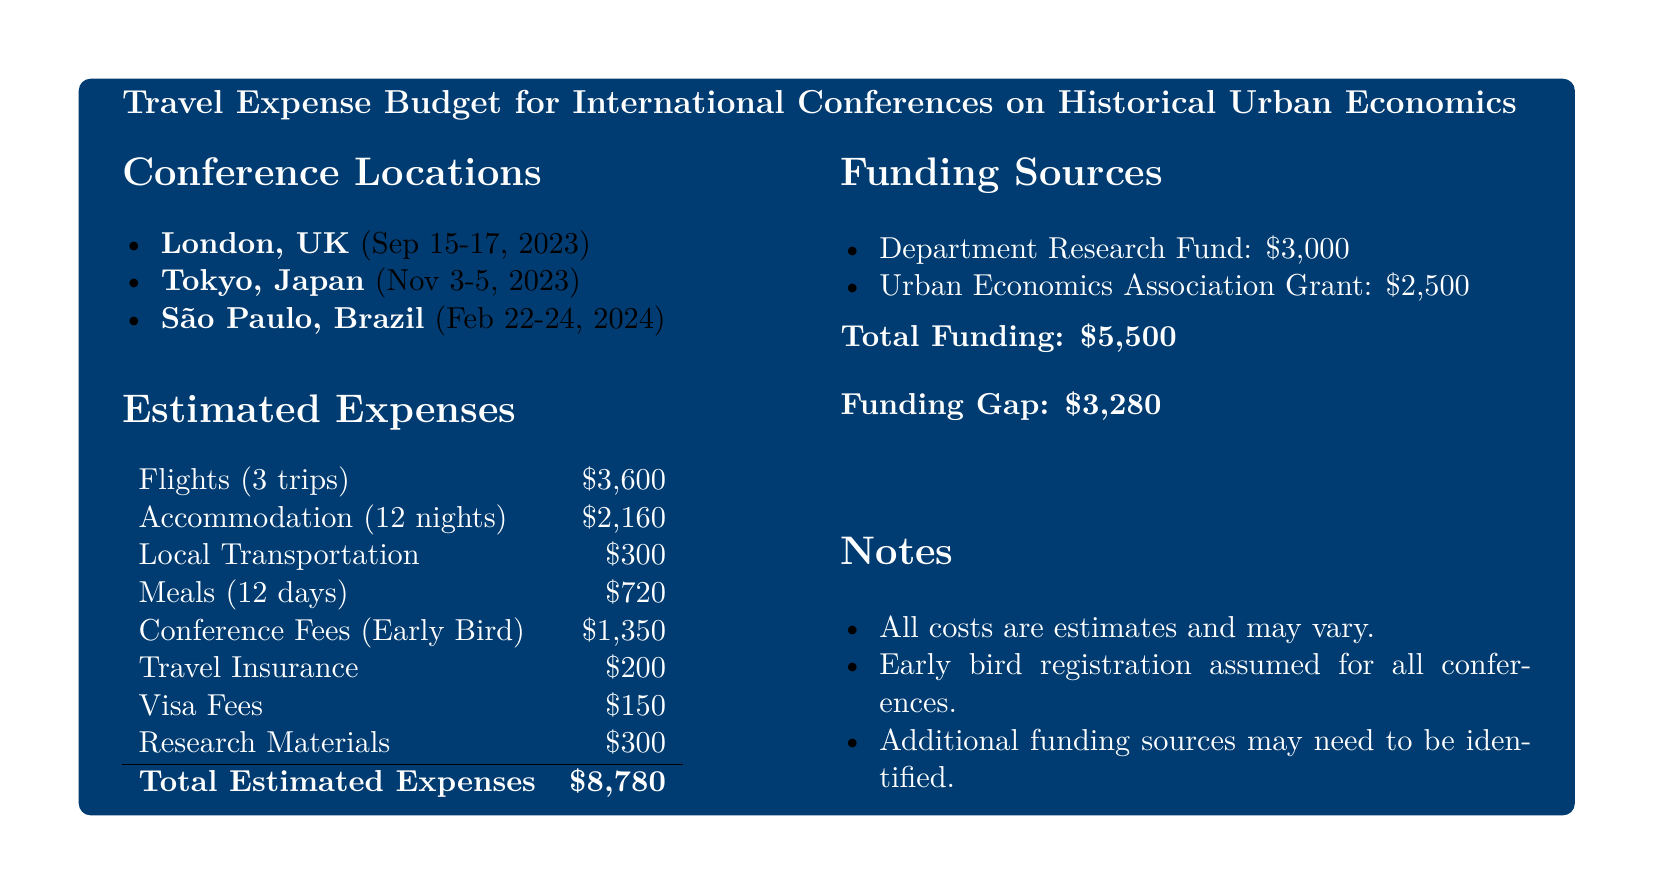What are the locations of the conferences? The locations of the conferences are mentioned in the document as London, Tokyo, and São Paulo.
Answer: London, Tokyo, São Paulo What is the total estimated expense for travel? The total estimated expenses are provided at the end of the expenses section, calculated from the various listed items.
Answer: $8,780 How many nights of accommodation are included in the budget? The budget specifies that there are 12 nights of accommodation accounted for in the estimated expenses.
Answer: 12 nights What is the funding gap? The funding gap is calculated by subtracting the total funding from the total estimated expenses in the budget.
Answer: $3,280 What is the amount allocated for conference fees? The document indicates the estimated amount for conference fees under the expenses section.
Answer: $1,350 Which grant contributes to the travel budget? The Urban Economics Association Grant is listed as one of the funding sources for the budget.
Answer: Urban Economics Association Grant How much is allocated for local transportation? The budget includes a specific amount for local transportation, listed in the estimated expenses.
Answer: $300 What is the estimated cost for meals? The estimated expenses section includes a specific line item for meals, which indicates the allocated amount.
Answer: $720 When is the conference in Tokyo scheduled? The document specifies the dates for the Tokyo conference, which can be found in the conference locations section.
Answer: Nov 3-5, 2023 